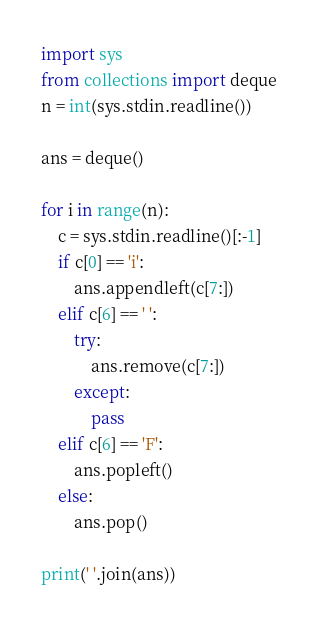Convert code to text. <code><loc_0><loc_0><loc_500><loc_500><_Python_>import sys
from collections import deque
n = int(sys.stdin.readline())

ans = deque()

for i in range(n):
    c = sys.stdin.readline()[:-1]
    if c[0] == 'i':
        ans.appendleft(c[7:])
    elif c[6] == ' ':
        try:
            ans.remove(c[7:])
        except:
            pass
    elif c[6] == 'F':
        ans.popleft()
    else:
        ans.pop()

print(' '.join(ans))</code> 